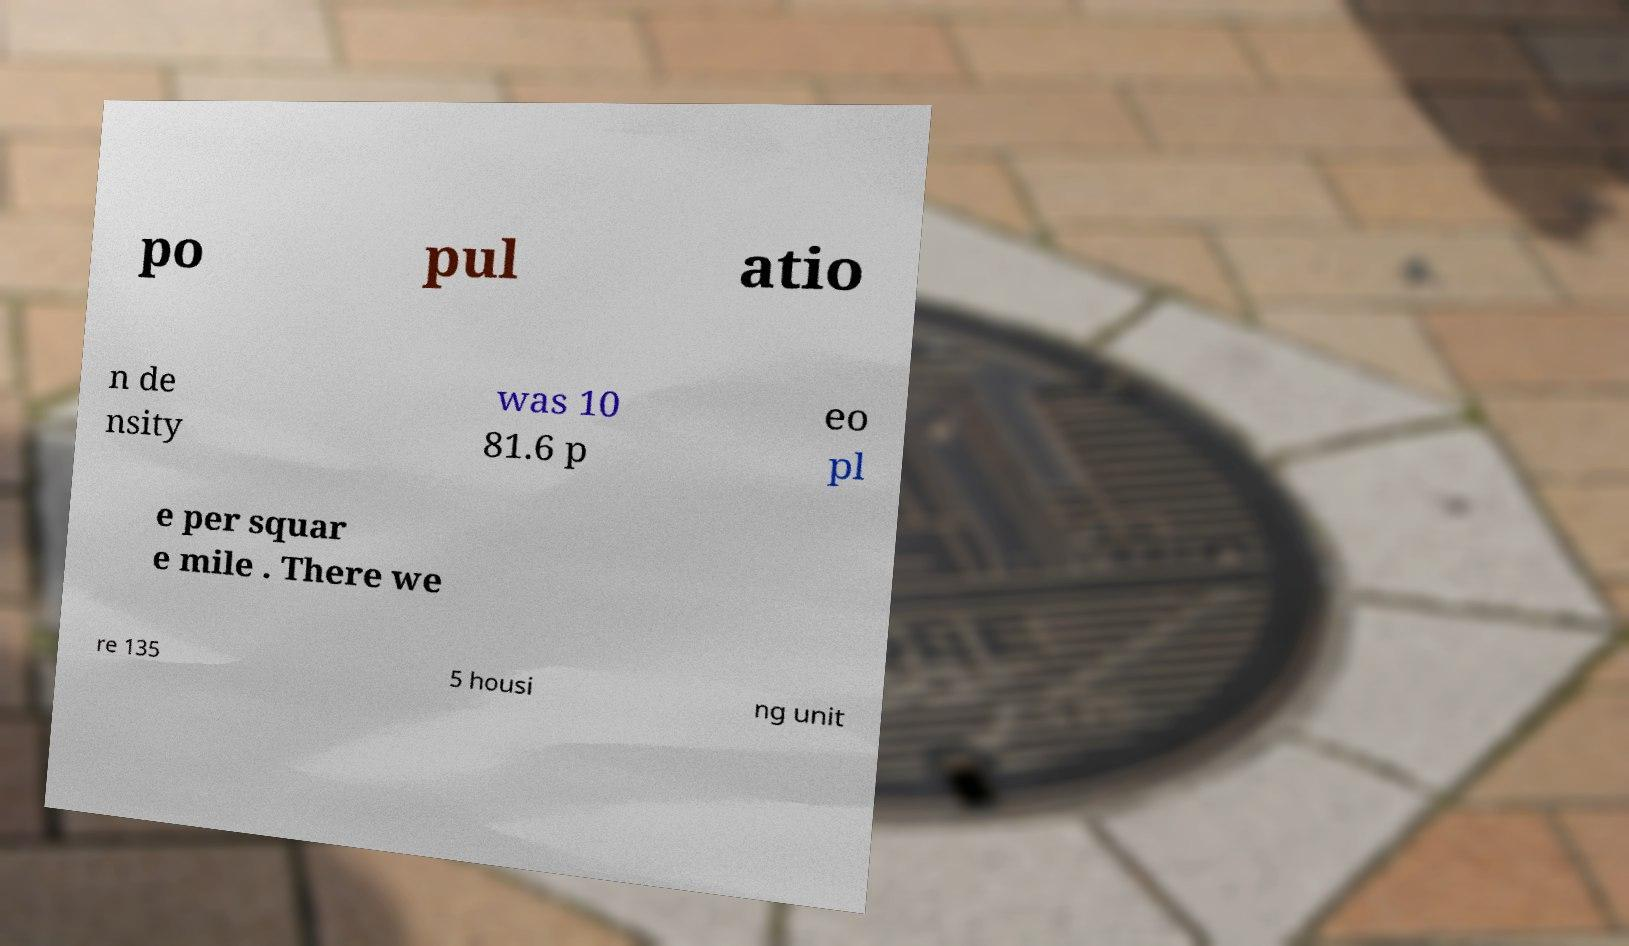What messages or text are displayed in this image? I need them in a readable, typed format. po pul atio n de nsity was 10 81.6 p eo pl e per squar e mile . There we re 135 5 housi ng unit 